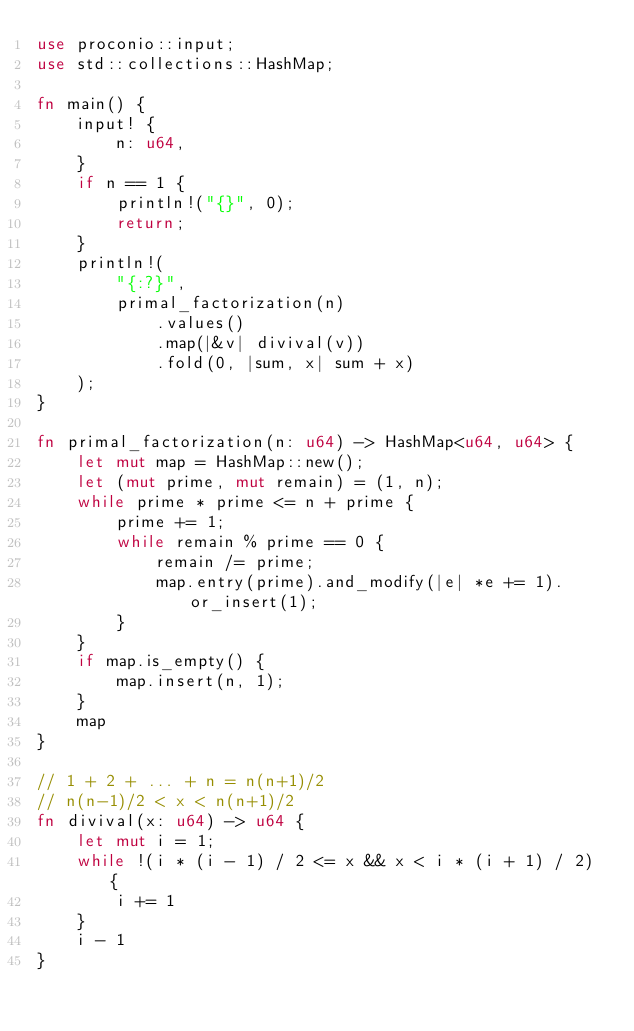<code> <loc_0><loc_0><loc_500><loc_500><_Rust_>use proconio::input;
use std::collections::HashMap;

fn main() {
    input! {
        n: u64,
    }
    if n == 1 {
        println!("{}", 0);
        return;
    }
    println!(
        "{:?}",
        primal_factorization(n)
            .values()
            .map(|&v| divival(v))
            .fold(0, |sum, x| sum + x)
    );
}

fn primal_factorization(n: u64) -> HashMap<u64, u64> {
    let mut map = HashMap::new();
    let (mut prime, mut remain) = (1, n);
    while prime * prime <= n + prime {
        prime += 1;
        while remain % prime == 0 {
            remain /= prime;
            map.entry(prime).and_modify(|e| *e += 1).or_insert(1);
        }
    }
    if map.is_empty() {
        map.insert(n, 1);
    }
    map
}

// 1 + 2 + ... + n = n(n+1)/2
// n(n-1)/2 < x < n(n+1)/2
fn divival(x: u64) -> u64 {
    let mut i = 1;
    while !(i * (i - 1) / 2 <= x && x < i * (i + 1) / 2) {
        i += 1
    }
    i - 1
}
</code> 